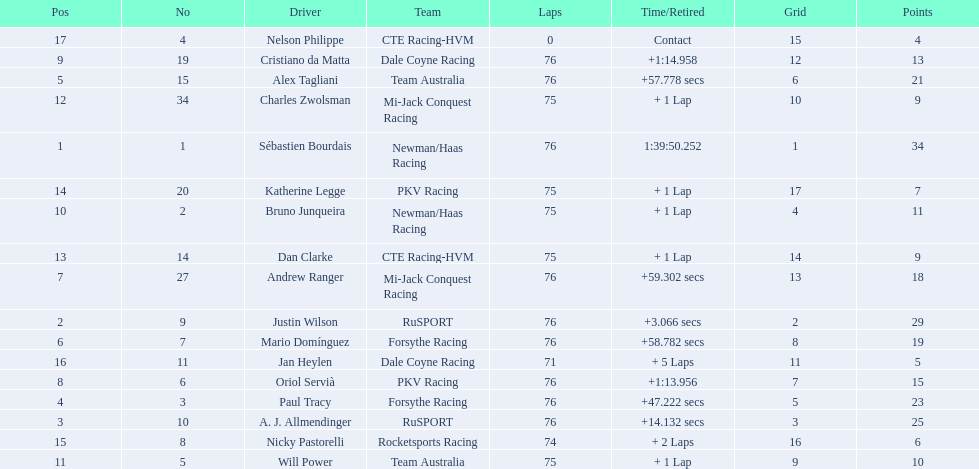What drivers took part in the 2006 tecate grand prix of monterrey? Sébastien Bourdais, Justin Wilson, A. J. Allmendinger, Paul Tracy, Alex Tagliani, Mario Domínguez, Andrew Ranger, Oriol Servià, Cristiano da Matta, Bruno Junqueira, Will Power, Charles Zwolsman, Dan Clarke, Katherine Legge, Nicky Pastorelli, Jan Heylen, Nelson Philippe. Which of those drivers scored the same amount of points as another driver? Charles Zwolsman, Dan Clarke. Who had the same amount of points as charles zwolsman? Dan Clarke. 